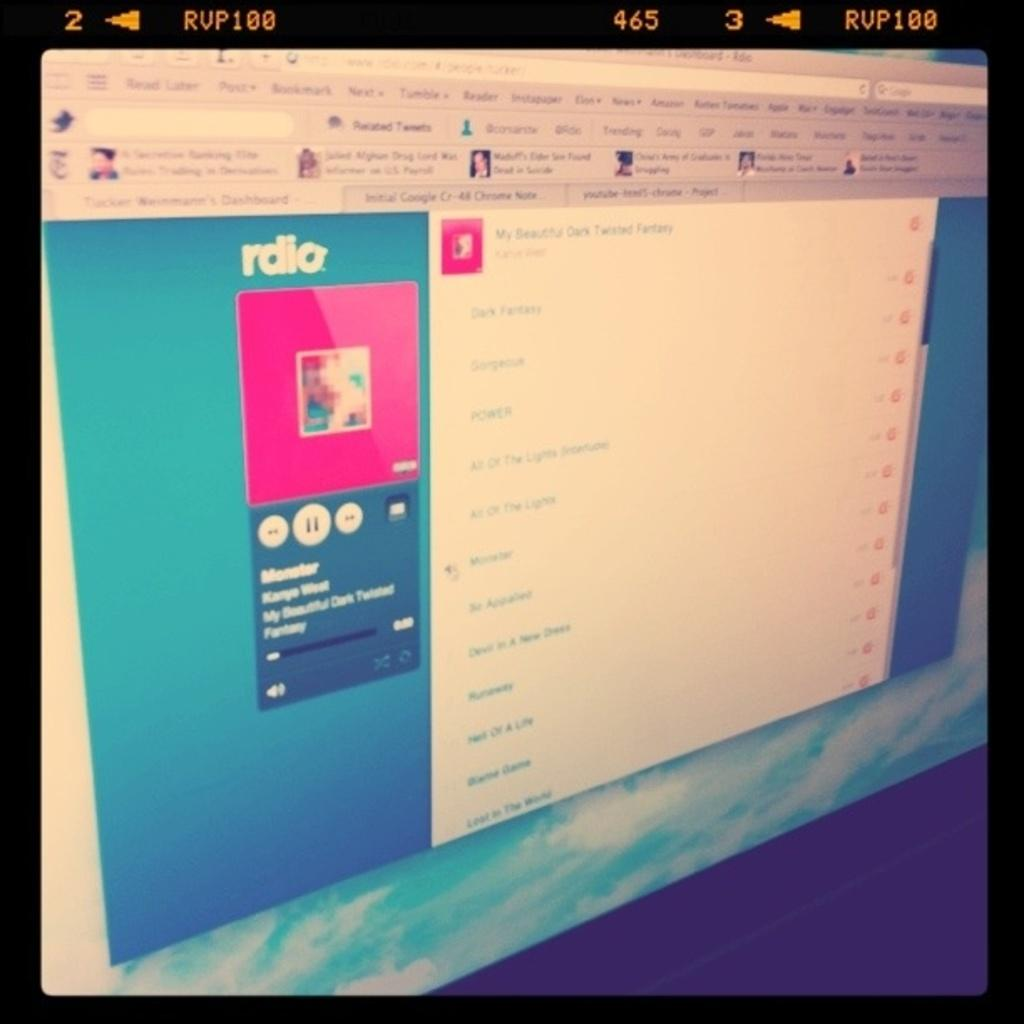Provide a one-sentence caption for the provided image. A computer display shows a page from the Rdio website. 